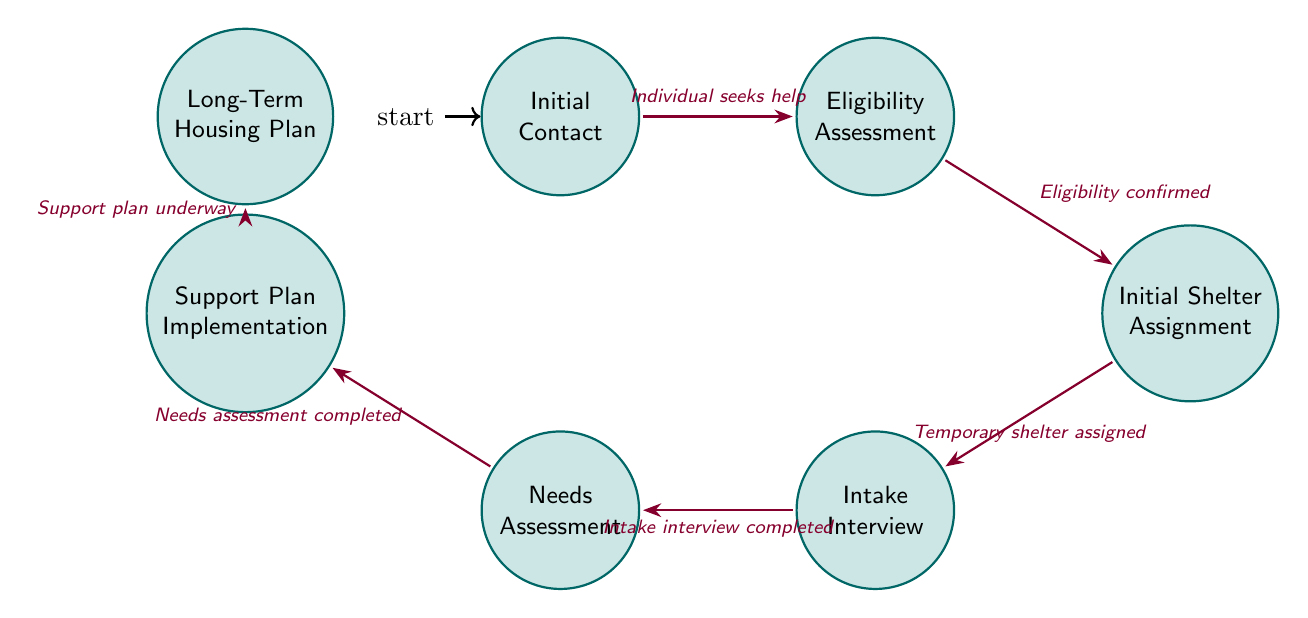What is the first state in the process? The first state in the shelter admission process is "Initial Contact," which is clearly indicated as the starting node in the diagram.
Answer: Initial Contact How many states are in the diagram? The diagram contains a total of seven states, which can be counted directly from the nodes represented in the diagram.
Answer: 7 What is the trigger for transitioning from "Initial Contact" to "Eligibility Assessment"? The trigger for this transition is indicated to be "Individual seeks help," as shown on the arrow connecting these two states.
Answer: Individual seeks help What is the last state in the process? The last state listed in the diagram is "Long-Term Housing Plan," which is located at the end of the flow, indicating the final stage of the process.
Answer: Long-Term Housing Plan What actions are performed during the "Needs Assessment"? The actions described in this state include "Develop a personalized support plan" and "Coordinate with healthcare, mental health, and other services," both of which are specified directly in the state description.
Answer: Develop a personalized support plan; Coordinate with healthcare, mental health, and other services What is the relationship between "Support Plan Implementation" and "Long-Term Housing Plan"? The relationship is that "Support Plan Implementation" leads to "Long-Term Housing Plan," signifying that once the support plan is underway, the focus shifts to long-term housing strategies as the next state in the diagram.
Answer: Transition from Support Plan Implementation to Long-Term Housing Plan What must happen before the "Intake Interview" can be conducted? According to the diagram, "Temporary shelter assigned" must happen before moving on to the "Intake Interview," as indicated by the transition path shown in the diagram.
Answer: Temporary shelter assigned What is the action at the "Initial Shelter Assignment" state? The actions performed during this state are "Match the individual to the appropriate shelter" and "Provide transportation if needed," both of which are outlined in the activities associated with this state in the diagram.
Answer: Match the individual to the appropriate shelter; Provide transportation if needed 